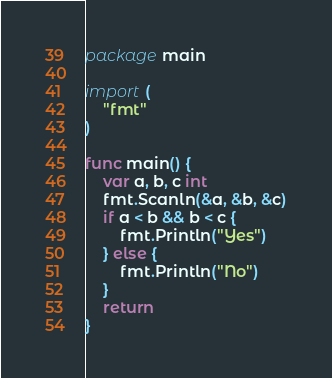Convert code to text. <code><loc_0><loc_0><loc_500><loc_500><_Go_>package main

import (
	"fmt"
)

func main() {
	var a, b, c int
	fmt.Scanln(&a, &b, &c)
	if a < b && b < c {
		fmt.Println("Yes")
	} else {
		fmt.Println("No")
	}
	return
}

</code> 